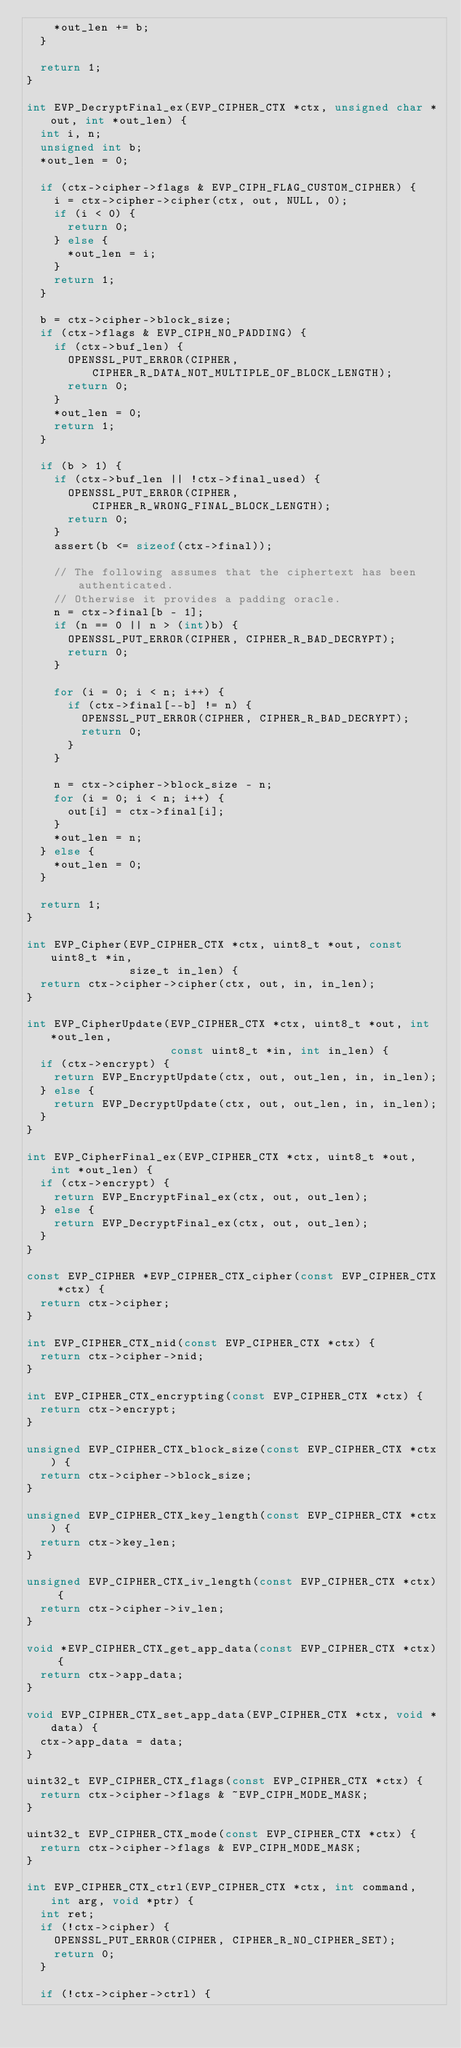<code> <loc_0><loc_0><loc_500><loc_500><_C_>    *out_len += b;
  }

  return 1;
}

int EVP_DecryptFinal_ex(EVP_CIPHER_CTX *ctx, unsigned char *out, int *out_len) {
  int i, n;
  unsigned int b;
  *out_len = 0;

  if (ctx->cipher->flags & EVP_CIPH_FLAG_CUSTOM_CIPHER) {
    i = ctx->cipher->cipher(ctx, out, NULL, 0);
    if (i < 0) {
      return 0;
    } else {
      *out_len = i;
    }
    return 1;
  }

  b = ctx->cipher->block_size;
  if (ctx->flags & EVP_CIPH_NO_PADDING) {
    if (ctx->buf_len) {
      OPENSSL_PUT_ERROR(CIPHER, CIPHER_R_DATA_NOT_MULTIPLE_OF_BLOCK_LENGTH);
      return 0;
    }
    *out_len = 0;
    return 1;
  }

  if (b > 1) {
    if (ctx->buf_len || !ctx->final_used) {
      OPENSSL_PUT_ERROR(CIPHER, CIPHER_R_WRONG_FINAL_BLOCK_LENGTH);
      return 0;
    }
    assert(b <= sizeof(ctx->final));

    // The following assumes that the ciphertext has been authenticated.
    // Otherwise it provides a padding oracle.
    n = ctx->final[b - 1];
    if (n == 0 || n > (int)b) {
      OPENSSL_PUT_ERROR(CIPHER, CIPHER_R_BAD_DECRYPT);
      return 0;
    }

    for (i = 0; i < n; i++) {
      if (ctx->final[--b] != n) {
        OPENSSL_PUT_ERROR(CIPHER, CIPHER_R_BAD_DECRYPT);
        return 0;
      }
    }

    n = ctx->cipher->block_size - n;
    for (i = 0; i < n; i++) {
      out[i] = ctx->final[i];
    }
    *out_len = n;
  } else {
    *out_len = 0;
  }

  return 1;
}

int EVP_Cipher(EVP_CIPHER_CTX *ctx, uint8_t *out, const uint8_t *in,
               size_t in_len) {
  return ctx->cipher->cipher(ctx, out, in, in_len);
}

int EVP_CipherUpdate(EVP_CIPHER_CTX *ctx, uint8_t *out, int *out_len,
                     const uint8_t *in, int in_len) {
  if (ctx->encrypt) {
    return EVP_EncryptUpdate(ctx, out, out_len, in, in_len);
  } else {
    return EVP_DecryptUpdate(ctx, out, out_len, in, in_len);
  }
}

int EVP_CipherFinal_ex(EVP_CIPHER_CTX *ctx, uint8_t *out, int *out_len) {
  if (ctx->encrypt) {
    return EVP_EncryptFinal_ex(ctx, out, out_len);
  } else {
    return EVP_DecryptFinal_ex(ctx, out, out_len);
  }
}

const EVP_CIPHER *EVP_CIPHER_CTX_cipher(const EVP_CIPHER_CTX *ctx) {
  return ctx->cipher;
}

int EVP_CIPHER_CTX_nid(const EVP_CIPHER_CTX *ctx) {
  return ctx->cipher->nid;
}

int EVP_CIPHER_CTX_encrypting(const EVP_CIPHER_CTX *ctx) {
  return ctx->encrypt;
}

unsigned EVP_CIPHER_CTX_block_size(const EVP_CIPHER_CTX *ctx) {
  return ctx->cipher->block_size;
}

unsigned EVP_CIPHER_CTX_key_length(const EVP_CIPHER_CTX *ctx) {
  return ctx->key_len;
}

unsigned EVP_CIPHER_CTX_iv_length(const EVP_CIPHER_CTX *ctx) {
  return ctx->cipher->iv_len;
}

void *EVP_CIPHER_CTX_get_app_data(const EVP_CIPHER_CTX *ctx) {
  return ctx->app_data;
}

void EVP_CIPHER_CTX_set_app_data(EVP_CIPHER_CTX *ctx, void *data) {
  ctx->app_data = data;
}

uint32_t EVP_CIPHER_CTX_flags(const EVP_CIPHER_CTX *ctx) {
  return ctx->cipher->flags & ~EVP_CIPH_MODE_MASK;
}

uint32_t EVP_CIPHER_CTX_mode(const EVP_CIPHER_CTX *ctx) {
  return ctx->cipher->flags & EVP_CIPH_MODE_MASK;
}

int EVP_CIPHER_CTX_ctrl(EVP_CIPHER_CTX *ctx, int command, int arg, void *ptr) {
  int ret;
  if (!ctx->cipher) {
    OPENSSL_PUT_ERROR(CIPHER, CIPHER_R_NO_CIPHER_SET);
    return 0;
  }

  if (!ctx->cipher->ctrl) {</code> 